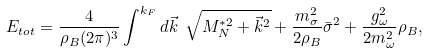<formula> <loc_0><loc_0><loc_500><loc_500>E _ { t o t } = \frac { 4 } { \rho _ { B } ( 2 \pi ) ^ { 3 } } \int ^ { k _ { F } } d \vec { k } \ \sqrt { M _ { N } ^ { * 2 } + \vec { k } ^ { 2 } } + \frac { m _ { \sigma } ^ { 2 } } { 2 \rho _ { B } } { \bar { \sigma } } ^ { 2 } + \frac { g _ { \omega } ^ { 2 } } { 2 m _ { \omega } ^ { 2 } } \rho _ { B } ,</formula> 